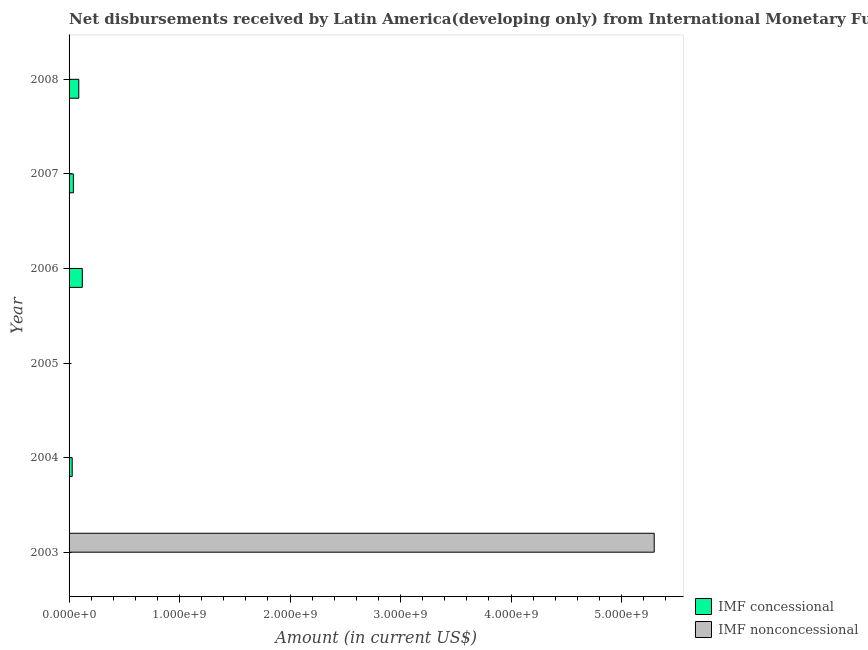How many different coloured bars are there?
Provide a short and direct response. 2. Are the number of bars per tick equal to the number of legend labels?
Provide a short and direct response. No. In how many cases, is the number of bars for a given year not equal to the number of legend labels?
Your response must be concise. 6. What is the net non concessional disbursements from imf in 2005?
Provide a short and direct response. 0. Across all years, what is the maximum net non concessional disbursements from imf?
Your answer should be compact. 5.30e+09. In which year was the net non concessional disbursements from imf maximum?
Give a very brief answer. 2003. What is the total net concessional disbursements from imf in the graph?
Give a very brief answer. 2.77e+08. What is the difference between the net concessional disbursements from imf in 2006 and that in 2008?
Ensure brevity in your answer.  3.19e+07. What is the difference between the net concessional disbursements from imf in 2005 and the net non concessional disbursements from imf in 2007?
Your response must be concise. 2.20e+06. What is the average net non concessional disbursements from imf per year?
Provide a succinct answer. 8.83e+08. In how many years, is the net non concessional disbursements from imf greater than 5200000000 US$?
Provide a succinct answer. 1. What is the ratio of the net concessional disbursements from imf in 2005 to that in 2008?
Give a very brief answer. 0.03. Is the net concessional disbursements from imf in 2005 less than that in 2008?
Give a very brief answer. Yes. What is the difference between the highest and the second highest net concessional disbursements from imf?
Ensure brevity in your answer.  3.19e+07. What is the difference between the highest and the lowest net concessional disbursements from imf?
Offer a very short reply. 1.20e+08. What is the difference between two consecutive major ticks on the X-axis?
Offer a terse response. 1.00e+09. Does the graph contain any zero values?
Offer a very short reply. Yes. Does the graph contain grids?
Provide a succinct answer. No. Where does the legend appear in the graph?
Give a very brief answer. Bottom right. How are the legend labels stacked?
Provide a short and direct response. Vertical. What is the title of the graph?
Provide a short and direct response. Net disbursements received by Latin America(developing only) from International Monetary Fund. What is the Amount (in current US$) in IMF nonconcessional in 2003?
Your answer should be compact. 5.30e+09. What is the Amount (in current US$) of IMF concessional in 2004?
Make the answer very short. 2.83e+07. What is the Amount (in current US$) in IMF nonconcessional in 2004?
Your response must be concise. 0. What is the Amount (in current US$) of IMF concessional in 2005?
Your response must be concise. 2.20e+06. What is the Amount (in current US$) in IMF nonconcessional in 2005?
Provide a succinct answer. 0. What is the Amount (in current US$) in IMF concessional in 2006?
Your answer should be very brief. 1.20e+08. What is the Amount (in current US$) of IMF concessional in 2007?
Your answer should be compact. 3.89e+07. What is the Amount (in current US$) in IMF nonconcessional in 2007?
Ensure brevity in your answer.  0. What is the Amount (in current US$) of IMF concessional in 2008?
Your answer should be compact. 8.81e+07. Across all years, what is the maximum Amount (in current US$) of IMF concessional?
Provide a succinct answer. 1.20e+08. Across all years, what is the maximum Amount (in current US$) in IMF nonconcessional?
Give a very brief answer. 5.30e+09. Across all years, what is the minimum Amount (in current US$) of IMF nonconcessional?
Offer a very short reply. 0. What is the total Amount (in current US$) in IMF concessional in the graph?
Keep it short and to the point. 2.77e+08. What is the total Amount (in current US$) of IMF nonconcessional in the graph?
Provide a succinct answer. 5.30e+09. What is the difference between the Amount (in current US$) of IMF concessional in 2004 and that in 2005?
Offer a terse response. 2.61e+07. What is the difference between the Amount (in current US$) in IMF concessional in 2004 and that in 2006?
Ensure brevity in your answer.  -9.16e+07. What is the difference between the Amount (in current US$) of IMF concessional in 2004 and that in 2007?
Provide a short and direct response. -1.06e+07. What is the difference between the Amount (in current US$) of IMF concessional in 2004 and that in 2008?
Keep it short and to the point. -5.98e+07. What is the difference between the Amount (in current US$) in IMF concessional in 2005 and that in 2006?
Ensure brevity in your answer.  -1.18e+08. What is the difference between the Amount (in current US$) of IMF concessional in 2005 and that in 2007?
Provide a succinct answer. -3.67e+07. What is the difference between the Amount (in current US$) of IMF concessional in 2005 and that in 2008?
Provide a succinct answer. -8.59e+07. What is the difference between the Amount (in current US$) of IMF concessional in 2006 and that in 2007?
Offer a terse response. 8.10e+07. What is the difference between the Amount (in current US$) of IMF concessional in 2006 and that in 2008?
Your answer should be compact. 3.19e+07. What is the difference between the Amount (in current US$) of IMF concessional in 2007 and that in 2008?
Make the answer very short. -4.91e+07. What is the average Amount (in current US$) of IMF concessional per year?
Ensure brevity in your answer.  4.62e+07. What is the average Amount (in current US$) in IMF nonconcessional per year?
Provide a short and direct response. 8.83e+08. What is the ratio of the Amount (in current US$) in IMF concessional in 2004 to that in 2005?
Your response must be concise. 12.86. What is the ratio of the Amount (in current US$) of IMF concessional in 2004 to that in 2006?
Make the answer very short. 0.24. What is the ratio of the Amount (in current US$) in IMF concessional in 2004 to that in 2007?
Keep it short and to the point. 0.73. What is the ratio of the Amount (in current US$) in IMF concessional in 2004 to that in 2008?
Offer a very short reply. 0.32. What is the ratio of the Amount (in current US$) of IMF concessional in 2005 to that in 2006?
Offer a terse response. 0.02. What is the ratio of the Amount (in current US$) in IMF concessional in 2005 to that in 2007?
Provide a succinct answer. 0.06. What is the ratio of the Amount (in current US$) in IMF concessional in 2005 to that in 2008?
Your answer should be very brief. 0.03. What is the ratio of the Amount (in current US$) of IMF concessional in 2006 to that in 2007?
Make the answer very short. 3.08. What is the ratio of the Amount (in current US$) of IMF concessional in 2006 to that in 2008?
Your answer should be very brief. 1.36. What is the ratio of the Amount (in current US$) of IMF concessional in 2007 to that in 2008?
Offer a terse response. 0.44. What is the difference between the highest and the second highest Amount (in current US$) in IMF concessional?
Keep it short and to the point. 3.19e+07. What is the difference between the highest and the lowest Amount (in current US$) in IMF concessional?
Give a very brief answer. 1.20e+08. What is the difference between the highest and the lowest Amount (in current US$) in IMF nonconcessional?
Give a very brief answer. 5.30e+09. 